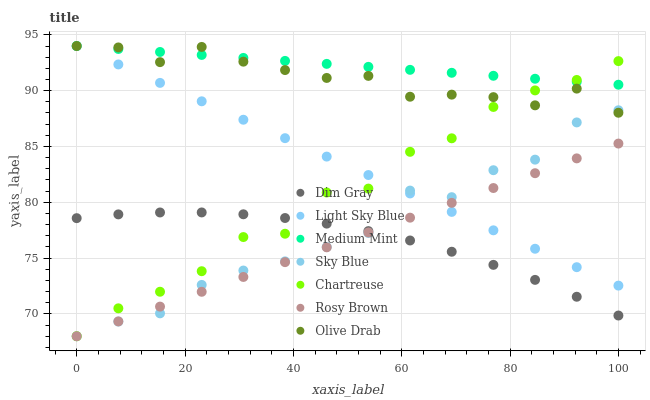Does Dim Gray have the minimum area under the curve?
Answer yes or no. Yes. Does Medium Mint have the maximum area under the curve?
Answer yes or no. Yes. Does Rosy Brown have the minimum area under the curve?
Answer yes or no. No. Does Rosy Brown have the maximum area under the curve?
Answer yes or no. No. Is Rosy Brown the smoothest?
Answer yes or no. Yes. Is Chartreuse the roughest?
Answer yes or no. Yes. Is Dim Gray the smoothest?
Answer yes or no. No. Is Dim Gray the roughest?
Answer yes or no. No. Does Rosy Brown have the lowest value?
Answer yes or no. Yes. Does Dim Gray have the lowest value?
Answer yes or no. No. Does Olive Drab have the highest value?
Answer yes or no. Yes. Does Rosy Brown have the highest value?
Answer yes or no. No. Is Dim Gray less than Light Sky Blue?
Answer yes or no. Yes. Is Medium Mint greater than Dim Gray?
Answer yes or no. Yes. Does Light Sky Blue intersect Medium Mint?
Answer yes or no. Yes. Is Light Sky Blue less than Medium Mint?
Answer yes or no. No. Is Light Sky Blue greater than Medium Mint?
Answer yes or no. No. Does Dim Gray intersect Light Sky Blue?
Answer yes or no. No. 